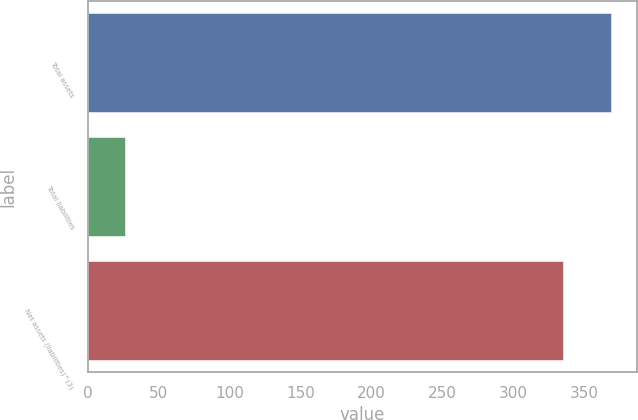<chart> <loc_0><loc_0><loc_500><loc_500><bar_chart><fcel>Total assets<fcel>Total liabilities<fcel>Net assets (liabilities)^(3)<nl><fcel>368.5<fcel>26<fcel>335<nl></chart> 